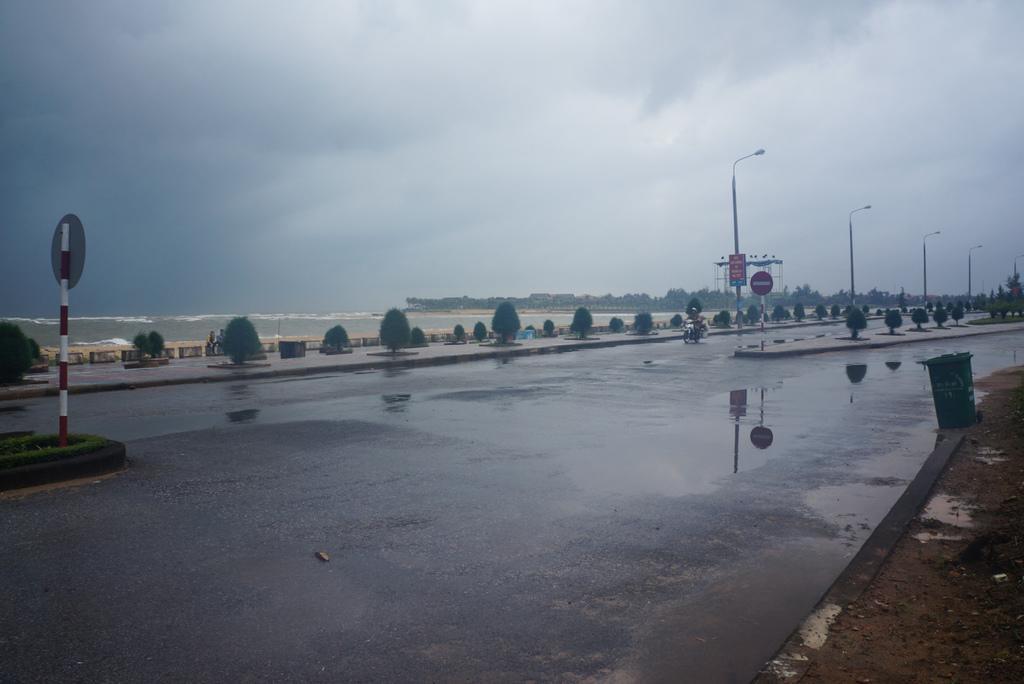Describe this image in one or two sentences. On the left side of the image we can see the water. In the background of the image we can see the trees, poles, lights, bushes, boards, road. On the right side of the image we can see a garbage bin. At the top of the image we can see the clouds in the sky. 